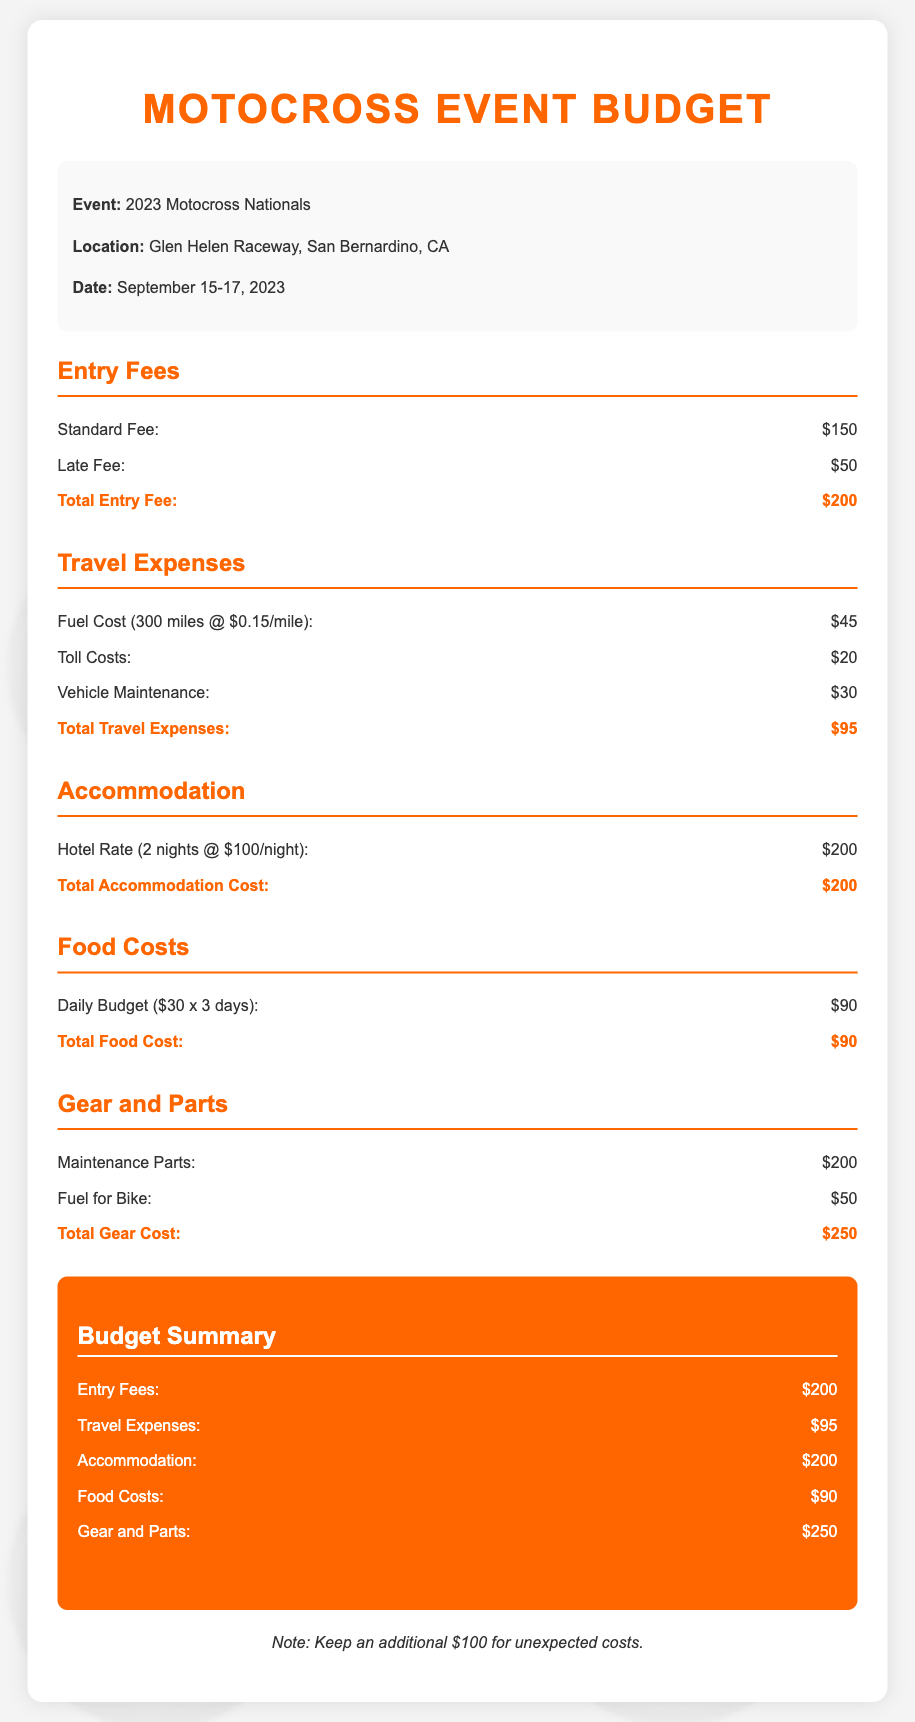What is the location of the event? The location of the event is specified in the document, which is Glen Helen Raceway, San Bernardino, CA.
Answer: Glen Helen Raceway, San Bernardino, CA What is the date of the event? The date of the event is mentioned as September 15-17, 2023.
Answer: September 15-17, 2023 What is the total entry fee? The total entry fee is stated clearly in the document as the sum of the standard fee and late fee, which is $150 + $50.
Answer: $200 What are the travel expenses? Travel expenses are detailed in the budget, and the total is $95, including fuel, tolls, and maintenance.
Answer: $95 How much is the hotel rate per night? The hotel rate is detailed in the accommodation section, listed as $100 per night.
Answer: $100 What is the total cost for food? The total food cost is specifically calculated as daily budget multiplied by the number of days, coming to $90.
Answer: $90 What is the total budget for gear and parts? The document sums up gear and parts costs to total $250, including maintenance parts and fuel for the bike.
Answer: $250 What is the grand total for the budget? The grand total is clearly stated as the sum of all expenses, which is $835.
Answer: $835 What additional amount is suggested for unexpected costs? The document notes to keep an additional amount for unexpected costs.
Answer: $100 